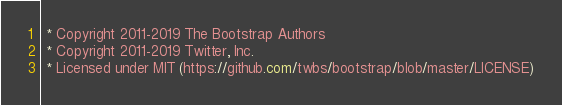Convert code to text. <code><loc_0><loc_0><loc_500><loc_500><_CSS_> * Copyright 2011-2019 The Bootstrap Authors
 * Copyright 2011-2019 Twitter, Inc.
 * Licensed under MIT (https://github.com/twbs/bootstrap/blob/master/LICENSE)</code> 